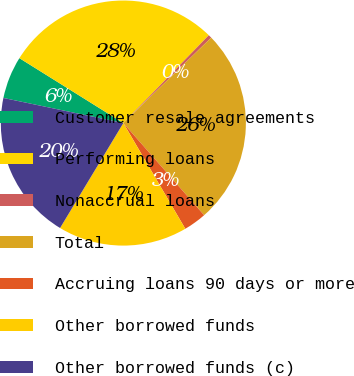Convert chart to OTSL. <chart><loc_0><loc_0><loc_500><loc_500><pie_chart><fcel>Customer resale agreements<fcel>Performing loans<fcel>Nonaccrual loans<fcel>Total<fcel>Accruing loans 90 days or more<fcel>Other borrowed funds<fcel>Other borrowed funds (c)<nl><fcel>5.6%<fcel>28.4%<fcel>0.44%<fcel>25.82%<fcel>3.02%<fcel>17.07%<fcel>19.65%<nl></chart> 